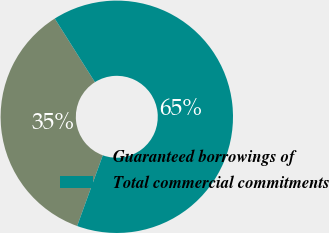Convert chart to OTSL. <chart><loc_0><loc_0><loc_500><loc_500><pie_chart><fcel>Guaranteed borrowings of<fcel>Total commercial commitments<nl><fcel>35.49%<fcel>64.51%<nl></chart> 